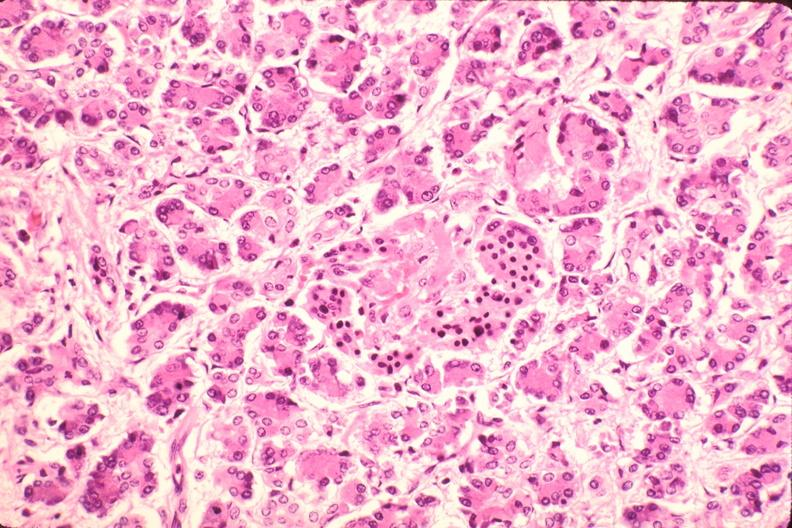does atherosclerosis show pancreas, microthrombi, thrombotic thrombocytopenic purpura?
Answer the question using a single word or phrase. No 